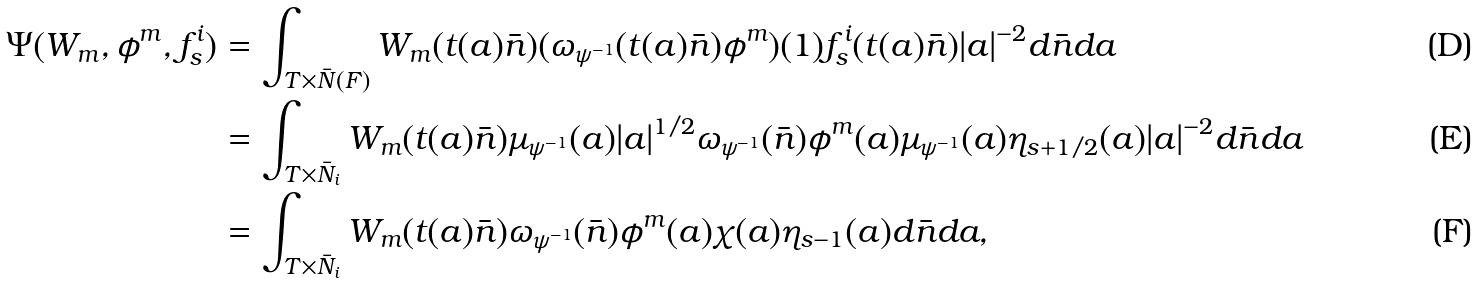<formula> <loc_0><loc_0><loc_500><loc_500>\Psi ( W _ { m } , \phi ^ { m } , f _ { s } ^ { i } ) & = \int _ { T \times \bar { N } ( F ) } W _ { m } ( t ( a ) \bar { n } ) ( \omega _ { \psi ^ { - 1 } } ( t ( a ) \bar { n } ) \phi ^ { m } ) ( 1 ) f _ { s } ^ { i } ( t ( a ) \bar { n } ) | a | ^ { - 2 } d \bar { n } d a \\ & = \int _ { T \times \bar { N } _ { i } } W _ { m } ( t ( a ) \bar { n } ) \mu _ { \psi ^ { - 1 } } ( a ) | a | ^ { 1 / 2 } \omega _ { \psi ^ { - 1 } } ( \bar { n } ) \phi ^ { m } ( a ) \mu _ { \psi ^ { - 1 } } ( a ) \eta _ { s + 1 / 2 } ( a ) | a | ^ { - 2 } d \bar { n } d a \\ & = \int _ { T \times \bar { N } _ { i } } W _ { m } ( t ( a ) \bar { n } ) \omega _ { \psi ^ { - 1 } } ( \bar { n } ) \phi ^ { m } ( a ) \chi ( a ) \eta _ { s - 1 } ( a ) d \bar { n } d a ,</formula> 